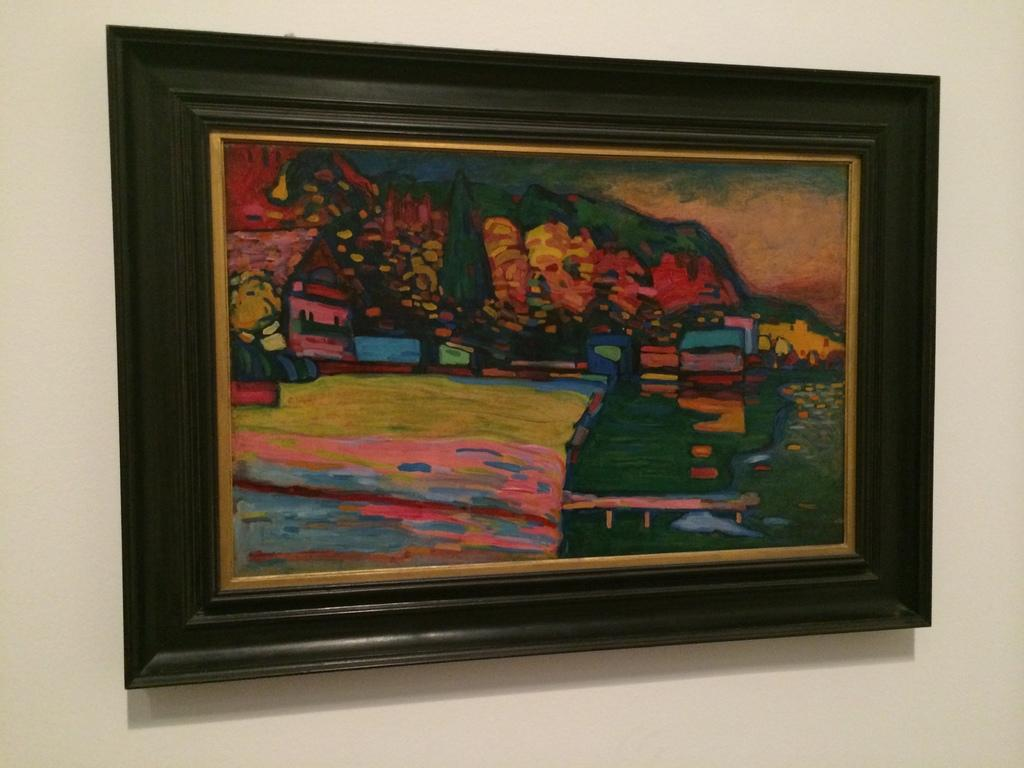What is the main feature in the center of the image? There is a wall in the center of the image. What is attached to the wall? There is a photo frame on the wall. How many legs can be seen in the image? There are no legs visible in the image; it only features a wall and a photo frame. What type of skin is present on the photo frame? The photo frame is an inanimate object and does not have skin. 